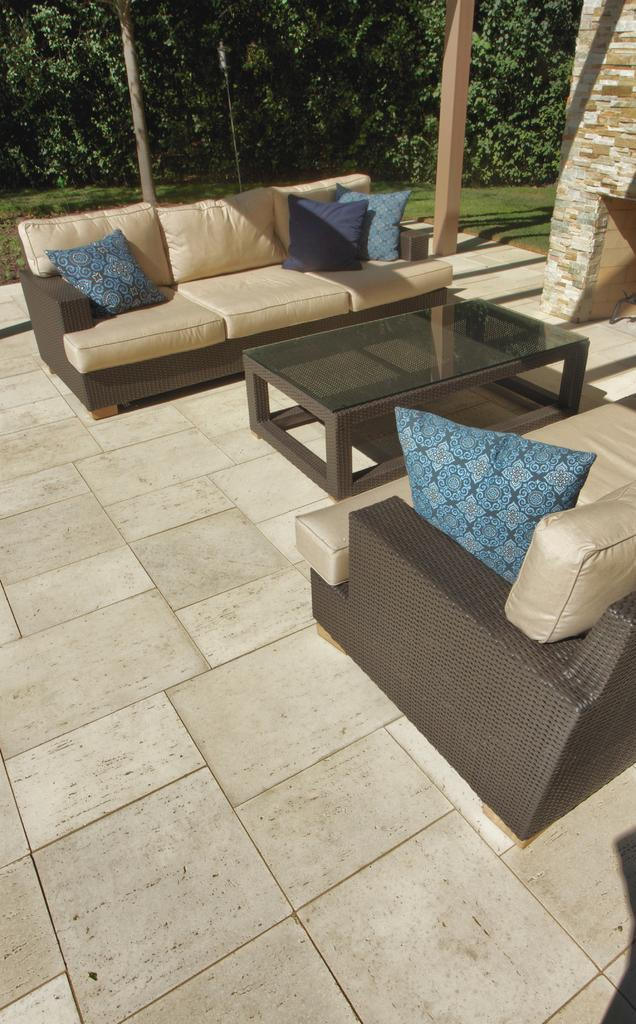What type of furniture is in the image? There is a sofa set in the image. What is placed on the sofa set? There are pillows on the sofa set. What other piece of furniture is in the image? There is a table on the floor in the image. What can be seen in the background of the image? Trees are visible in the background of the image. What type of match is being played on the table in the image? There is no match being played on the table in the image; it is a regular table with no game visible. 